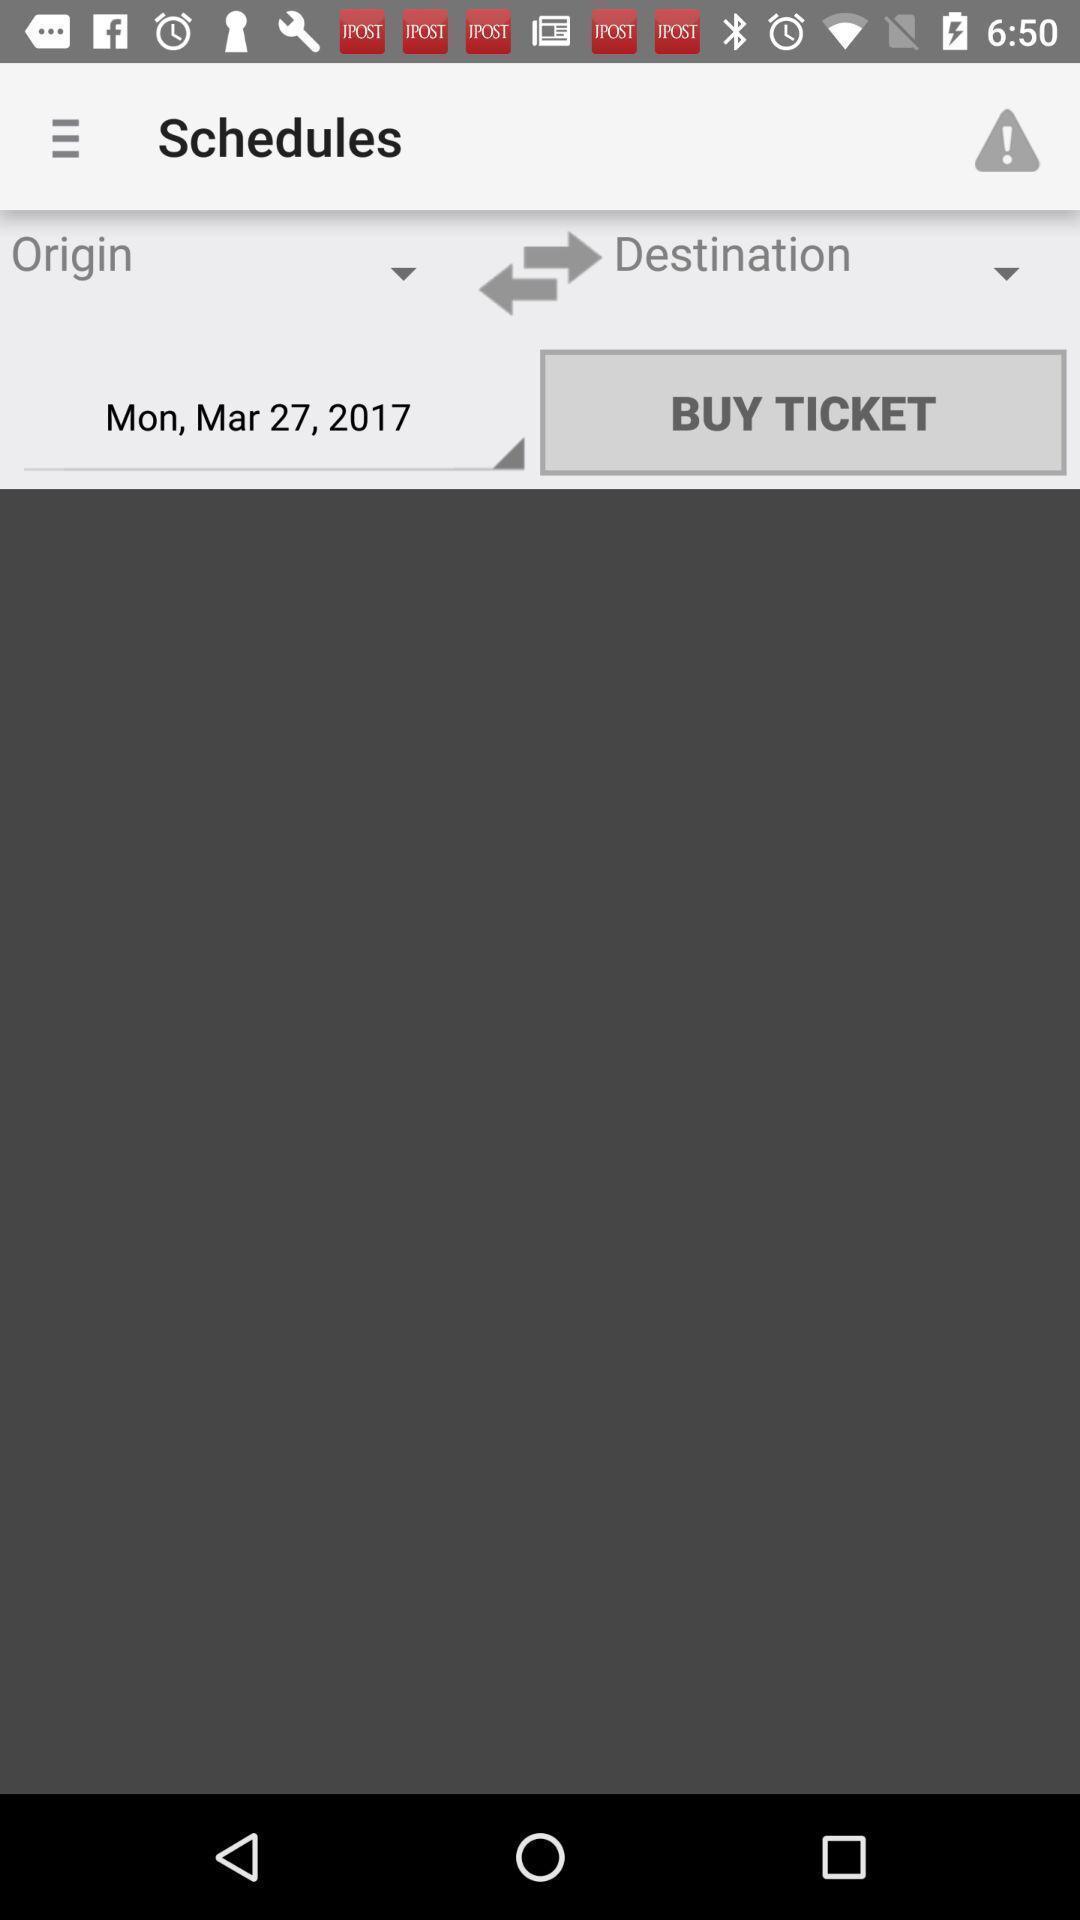What details can you identify in this image? Ticket confirmation page displayed of a travelling app. 